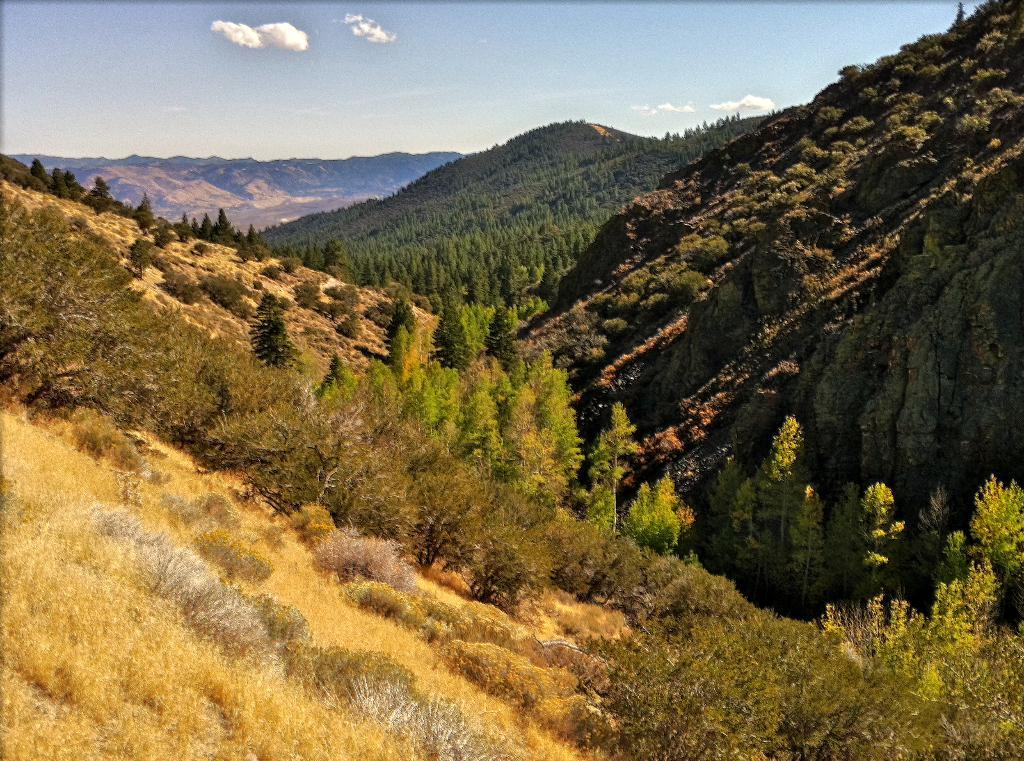What type of vegetation can be seen on the mountains in the image? Trees are present on the mountains in the image. What is the condition of the sky in the image? The sky is cloudy at the top of the image. What type of quince can be seen hanging from the trees on the mountains in the image? There is no quince present in the image; only trees are visible on the mountains. What kind of fowl can be seen flying in the cloudy sky in the image? There are no birds or fowl visible in the image; only trees on the mountains and a cloudy sky are present. 